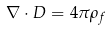<formula> <loc_0><loc_0><loc_500><loc_500>\nabla \cdot D = 4 \pi \rho _ { f }</formula> 